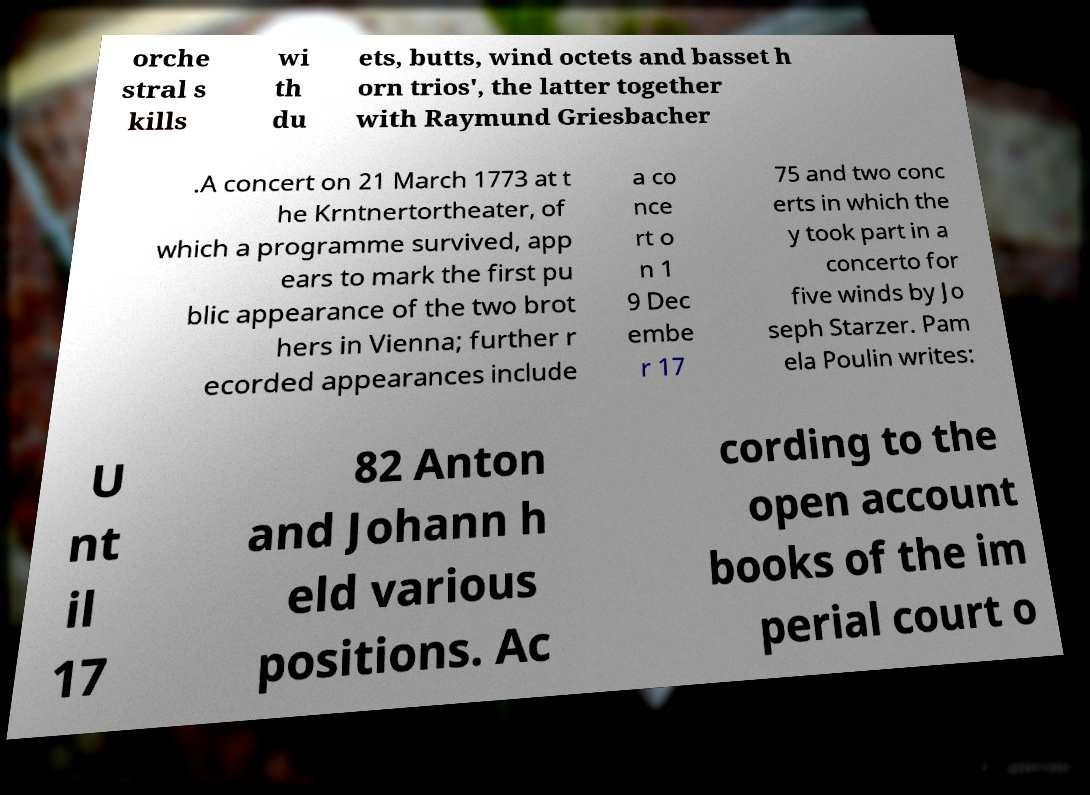Could you assist in decoding the text presented in this image and type it out clearly? orche stral s kills wi th du ets, butts, wind octets and basset h orn trios', the latter together with Raymund Griesbacher .A concert on 21 March 1773 at t he Krntnertortheater, of which a programme survived, app ears to mark the first pu blic appearance of the two brot hers in Vienna; further r ecorded appearances include a co nce rt o n 1 9 Dec embe r 17 75 and two conc erts in which the y took part in a concerto for five winds by Jo seph Starzer. Pam ela Poulin writes: U nt il 17 82 Anton and Johann h eld various positions. Ac cording to the open account books of the im perial court o 